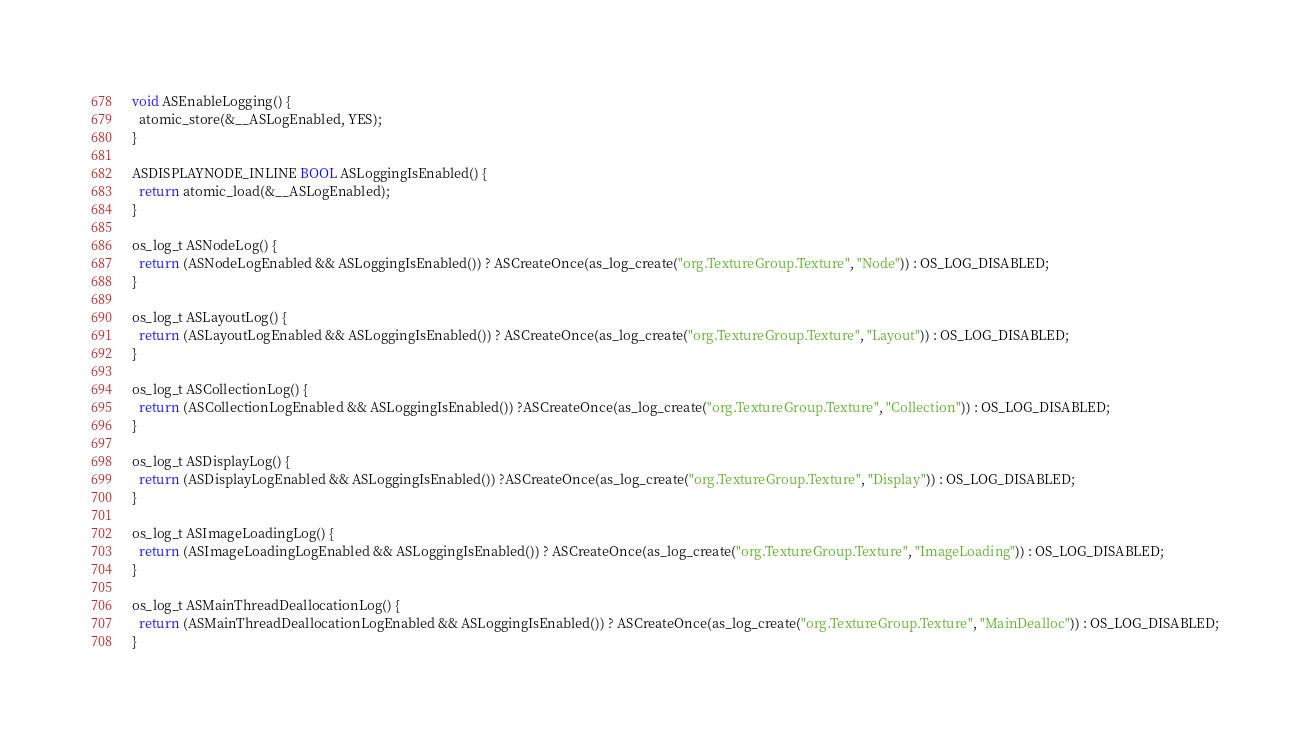Convert code to text. <code><loc_0><loc_0><loc_500><loc_500><_ObjectiveC_>void ASEnableLogging() {
  atomic_store(&__ASLogEnabled, YES);
}

ASDISPLAYNODE_INLINE BOOL ASLoggingIsEnabled() {
  return atomic_load(&__ASLogEnabled);
}

os_log_t ASNodeLog() {
  return (ASNodeLogEnabled && ASLoggingIsEnabled()) ? ASCreateOnce(as_log_create("org.TextureGroup.Texture", "Node")) : OS_LOG_DISABLED;
}

os_log_t ASLayoutLog() {
  return (ASLayoutLogEnabled && ASLoggingIsEnabled()) ? ASCreateOnce(as_log_create("org.TextureGroup.Texture", "Layout")) : OS_LOG_DISABLED;
}

os_log_t ASCollectionLog() {
  return (ASCollectionLogEnabled && ASLoggingIsEnabled()) ?ASCreateOnce(as_log_create("org.TextureGroup.Texture", "Collection")) : OS_LOG_DISABLED;
}

os_log_t ASDisplayLog() {
  return (ASDisplayLogEnabled && ASLoggingIsEnabled()) ?ASCreateOnce(as_log_create("org.TextureGroup.Texture", "Display")) : OS_LOG_DISABLED;
}

os_log_t ASImageLoadingLog() {
  return (ASImageLoadingLogEnabled && ASLoggingIsEnabled()) ? ASCreateOnce(as_log_create("org.TextureGroup.Texture", "ImageLoading")) : OS_LOG_DISABLED;
}

os_log_t ASMainThreadDeallocationLog() {
  return (ASMainThreadDeallocationLogEnabled && ASLoggingIsEnabled()) ? ASCreateOnce(as_log_create("org.TextureGroup.Texture", "MainDealloc")) : OS_LOG_DISABLED;
}
</code> 